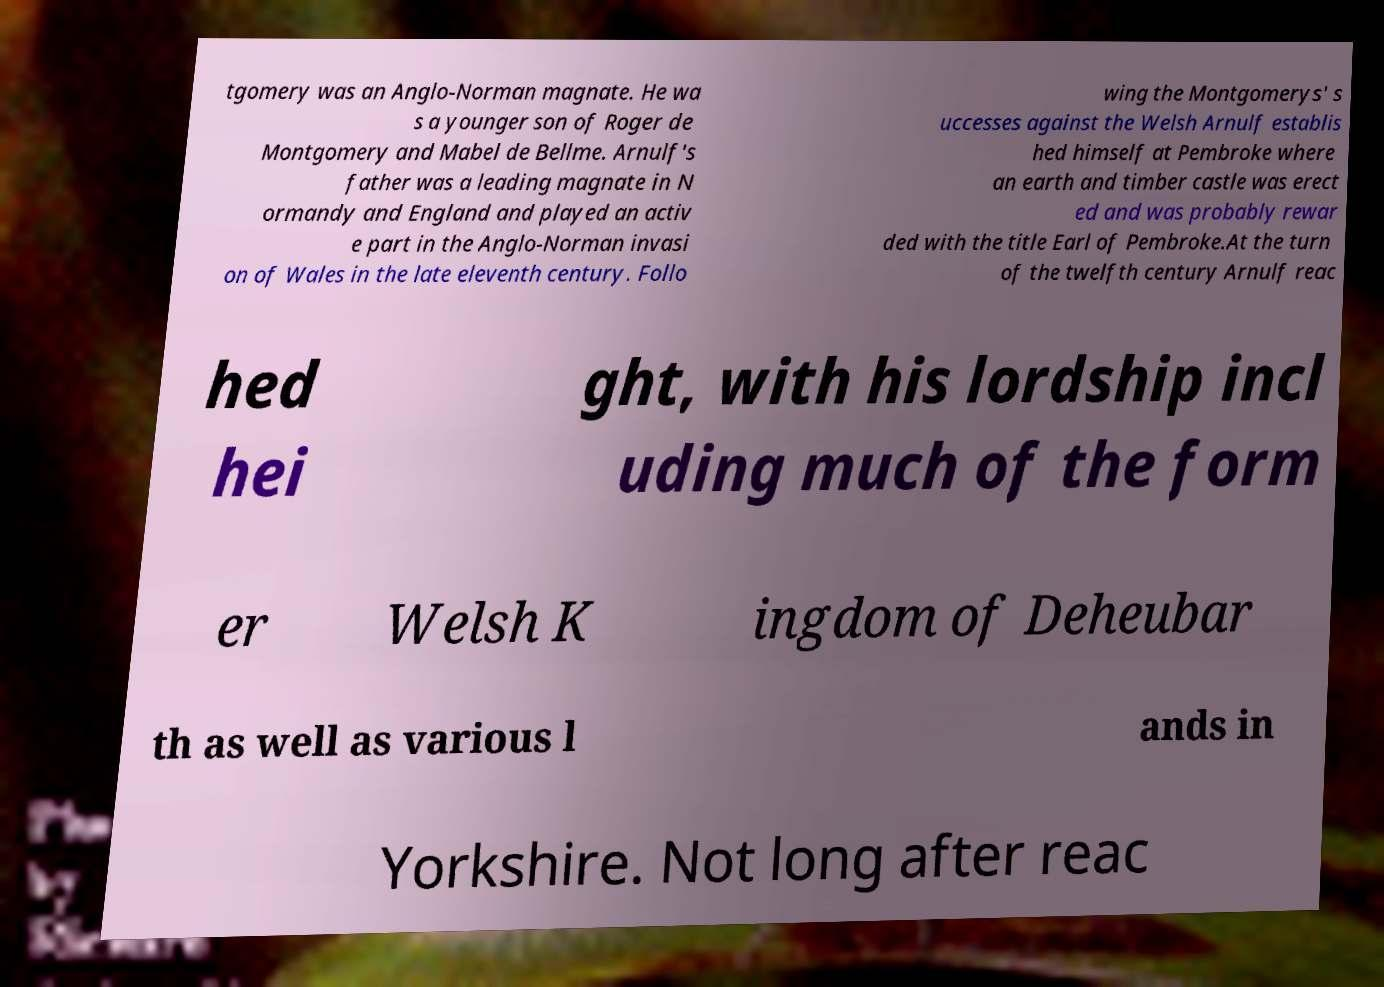There's text embedded in this image that I need extracted. Can you transcribe it verbatim? tgomery was an Anglo-Norman magnate. He wa s a younger son of Roger de Montgomery and Mabel de Bellme. Arnulf's father was a leading magnate in N ormandy and England and played an activ e part in the Anglo-Norman invasi on of Wales in the late eleventh century. Follo wing the Montgomerys' s uccesses against the Welsh Arnulf establis hed himself at Pembroke where an earth and timber castle was erect ed and was probably rewar ded with the title Earl of Pembroke.At the turn of the twelfth century Arnulf reac hed hei ght, with his lordship incl uding much of the form er Welsh K ingdom of Deheubar th as well as various l ands in Yorkshire. Not long after reac 